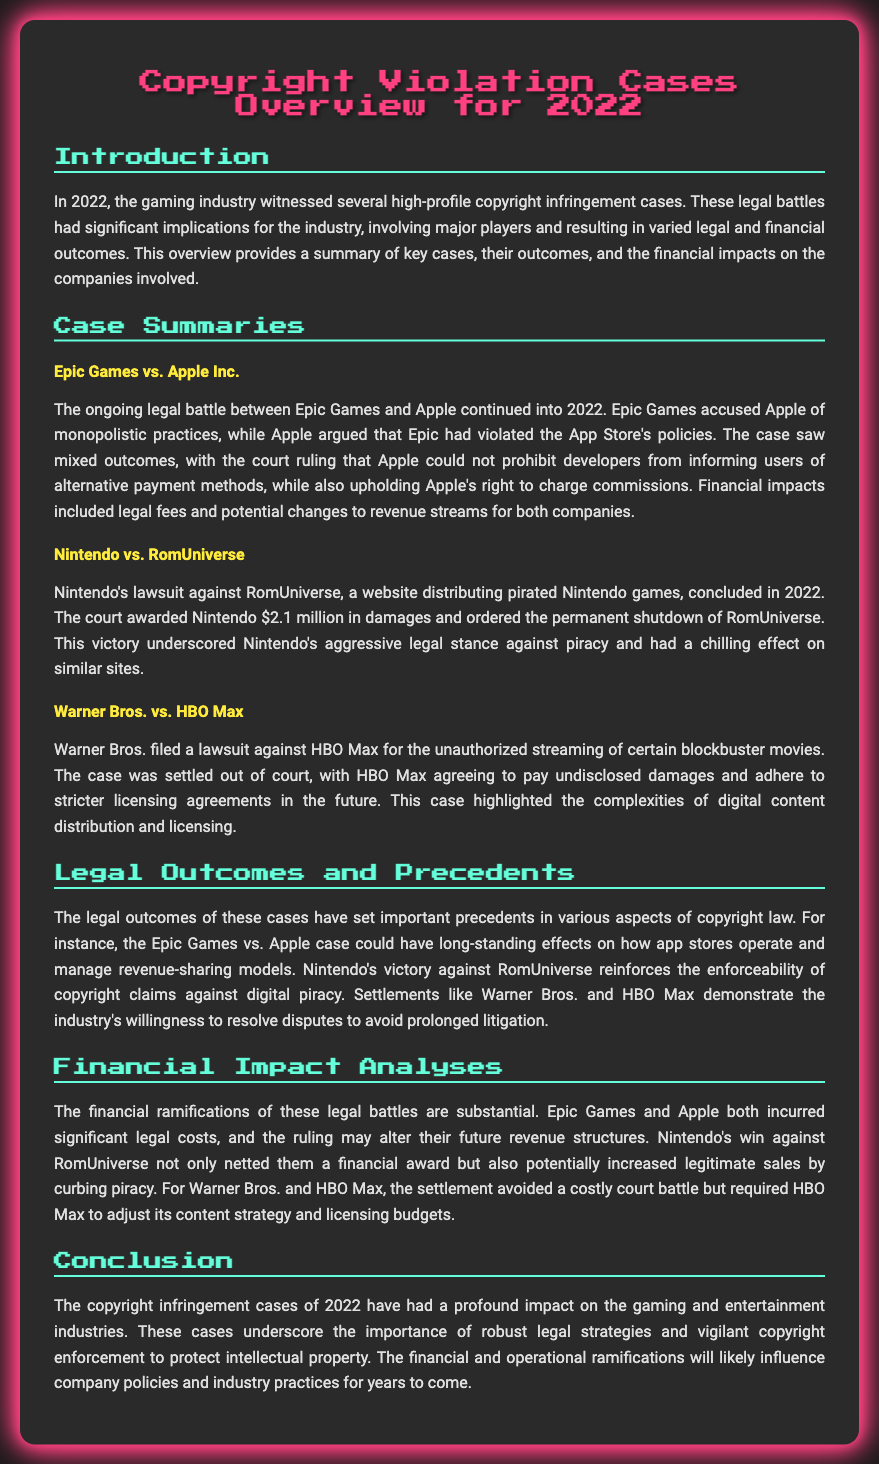What was the outcome of Epic Games vs. Apple Inc.? The legal battle resulted in mixed outcomes, with the court ruling that Apple could not prohibit developers from informing users of alternative payment methods, while also upholding Apple's right to charge commissions.
Answer: Mixed outcomes What was the amount awarded to Nintendo in the RomUniverse case? The court awarded Nintendo $2.1 million in damages.
Answer: $2.1 million What was the status of RomUniverse after the lawsuit? The court ordered the permanent shutdown of RomUniverse.
Answer: Permanent shutdown What was highlighted by the Warner Bros. vs. HBO Max case? The complexities of digital content distribution and licensing.
Answer: Complexities of digital content distribution How did the Epic Games vs. Apple ruling potentially affect app stores? It could have long-standing effects on how app stores operate and manage revenue-sharing models.
Answer: Long-standing effects What was the conclusion regarding the impact of these cases on the industry? The copyright infringement cases of 2022 have had a profound impact on the gaming and entertainment industries.
Answer: Profound impact What type of law did the outcomes of these cases relate to? Copyright law.
Answer: Copyright law What was a financial consequence for Nintendo from the RomUniverse case? It potentially increased legitimate sales by curbing piracy.
Answer: Increased legitimate sales What was the outcome for HBO Max in the Warner Bros. case? HBO Max agreed to pay undisclosed damages and adhere to stricter licensing agreements.
Answer: Agreed to pay damages 